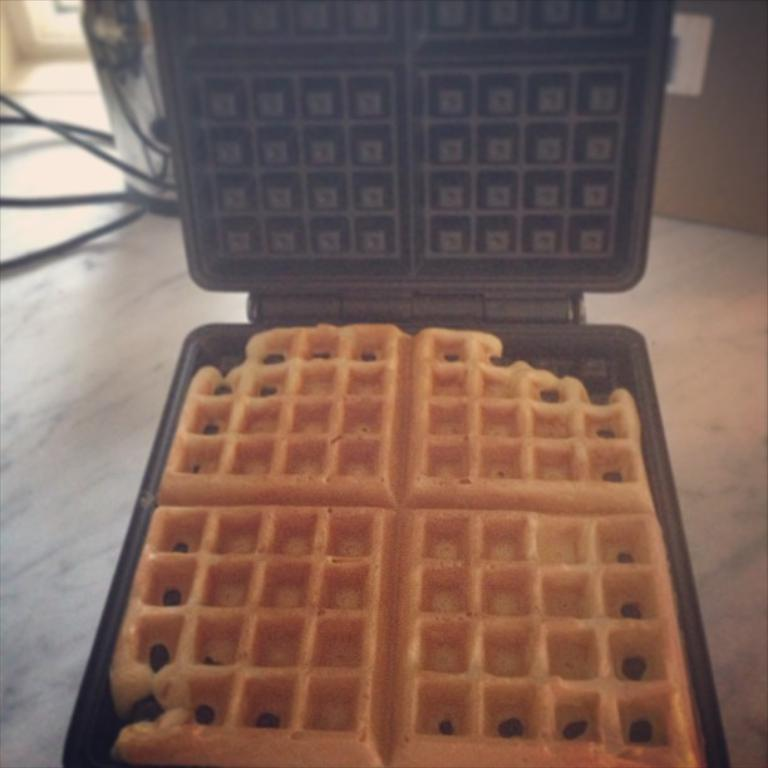What type of food is visible in the image? There is a waffle in the image. What other object can be seen in the image? There is a machine in the image. How many feet are visible in the image? There are no feet visible in the image. Is the family gathered around the waffle in the image? There is no information about a family in the image, so we cannot determine if they are gathered around the waffle. 